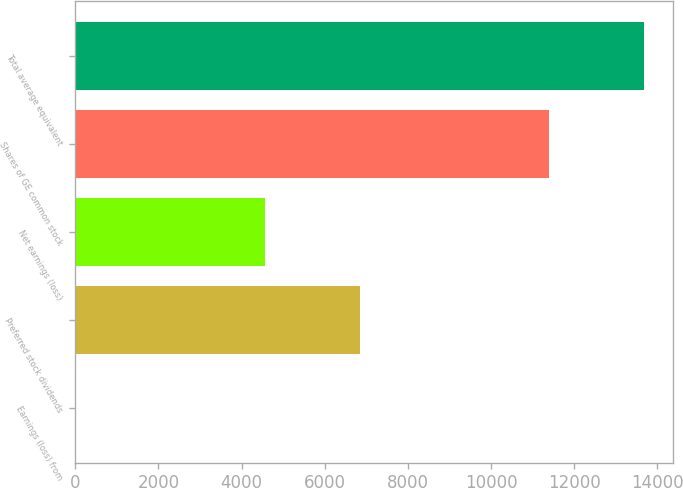<chart> <loc_0><loc_0><loc_500><loc_500><bar_chart><fcel>Earnings (loss) from<fcel>Preferred stock dividends<fcel>Net earnings (loss)<fcel>Shares of GE common stock<fcel>Total average equivalent<nl><fcel>0.2<fcel>6842.84<fcel>4561.96<fcel>11404.6<fcel>13685.5<nl></chart> 